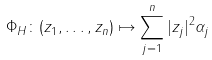Convert formula to latex. <formula><loc_0><loc_0><loc_500><loc_500>\label l { P h i H } \Phi _ { H } \colon ( z _ { 1 } , \dots , z _ { n } ) \mapsto \sum _ { j = 1 } ^ { n } | z _ { j } | ^ { 2 } \alpha _ { j }</formula> 